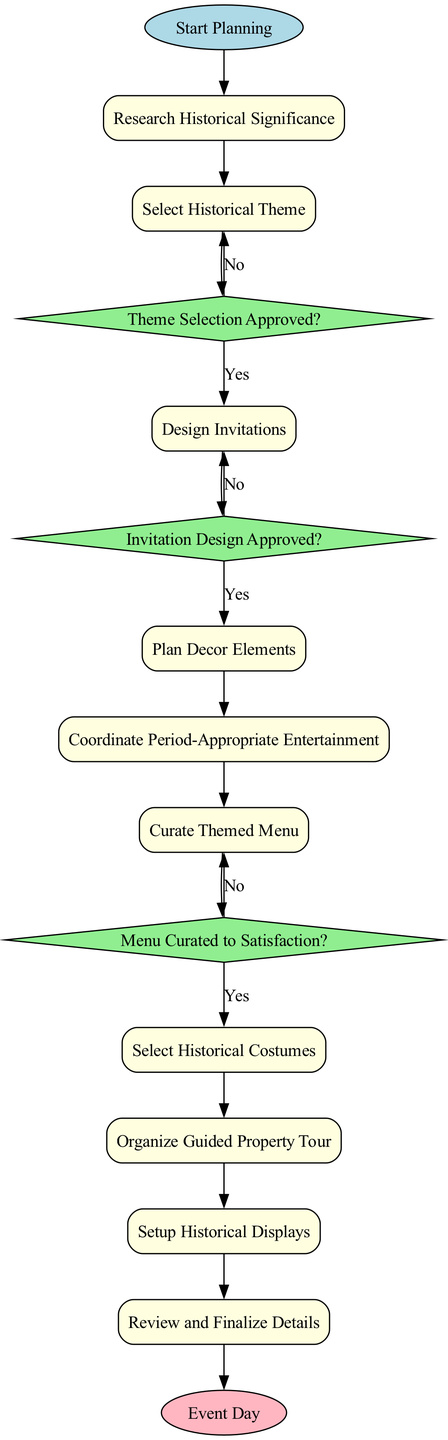What is the starting activity in the diagram? The starting activity is indicated at the top of the diagram, labeled as "Start Planning." This is the first node in the flow, which kicks off the planning process.
Answer: Start Planning How many activities are there in total? By counting the rectangular nodes labeled as activities in the diagram, there are 10 activities listed. Each activity corresponds to a step in organizing the wedding reception.
Answer: 10 What is the last step before the event day? The last step before reaching the "Event Day" is labeled as "Review and Finalize Details," which is the final activity in the flow before the completion of the reception planning.
Answer: Review and Finalize Details Which decision node follows the activity "Select Historical Theme"? The decision that follows the "Select Historical Theme" activity is "Theme Selection Approved?" This decision assesses whether the chosen theme is approved, influencing the subsequent activities.
Answer: Theme Selection Approved? What happens if the invitation design is not approved? If the invitation design is not approved, the flow leads back to the previous activity "Design Invitations," indicating that the design needs to be revised before moving forward.
Answer: Design Invitations What is the purpose of the node "Organize Guided Property Tour"? The node "Organize Guided Property Tour" serves the purpose of scheduling tours to educate guests about the property's history, enhancing their experience at the reception.
Answer: Schedule tours Which node represents decision approval related to the menu? The decision node representing approval related to the menu is "Menu Curated to Satisfaction?" This decision checks whether the proposed menu meets satisfactory criteria before proceeding to select costumes.
Answer: Menu Curated to Satisfaction? What activity occurs immediately after designing the invitations? Immediately following the "Design Invitations" activity is the decision "Invitation Design Approved?" This decision evaluates the approval status of the invitations designed.
Answer: Invitation Design Approved? Which two activities are connected directly before setting up historical displays? The two activities directly connected before the "Setup Historical Displays" node are "Select Historical Costumes" and "Organize Guided Property Tour." These steps build on each other in the flow.
Answer: Select Historical Costumes, Organize Guided Property Tour 